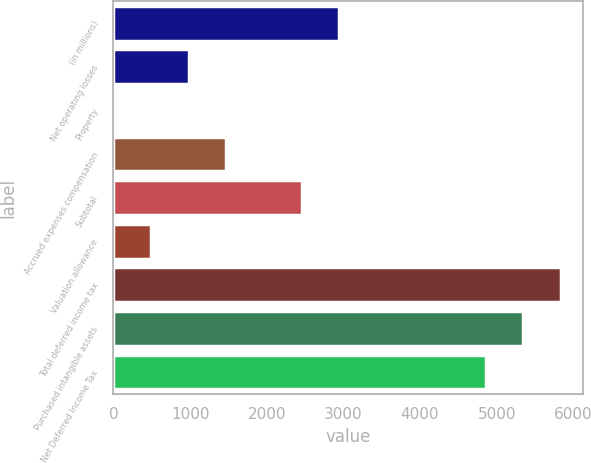<chart> <loc_0><loc_0><loc_500><loc_500><bar_chart><fcel>(in millions)<fcel>Net operating losses<fcel>Property<fcel>Accrued expenses compensation<fcel>Subtotal<fcel>Valuation allowance<fcel>Total deferred income tax<fcel>Purchased intangible assets<fcel>Net Deferred Income Tax<nl><fcel>2943.52<fcel>984.84<fcel>5.5<fcel>1474.51<fcel>2453.85<fcel>495.17<fcel>5837.04<fcel>5347.37<fcel>4857.7<nl></chart> 